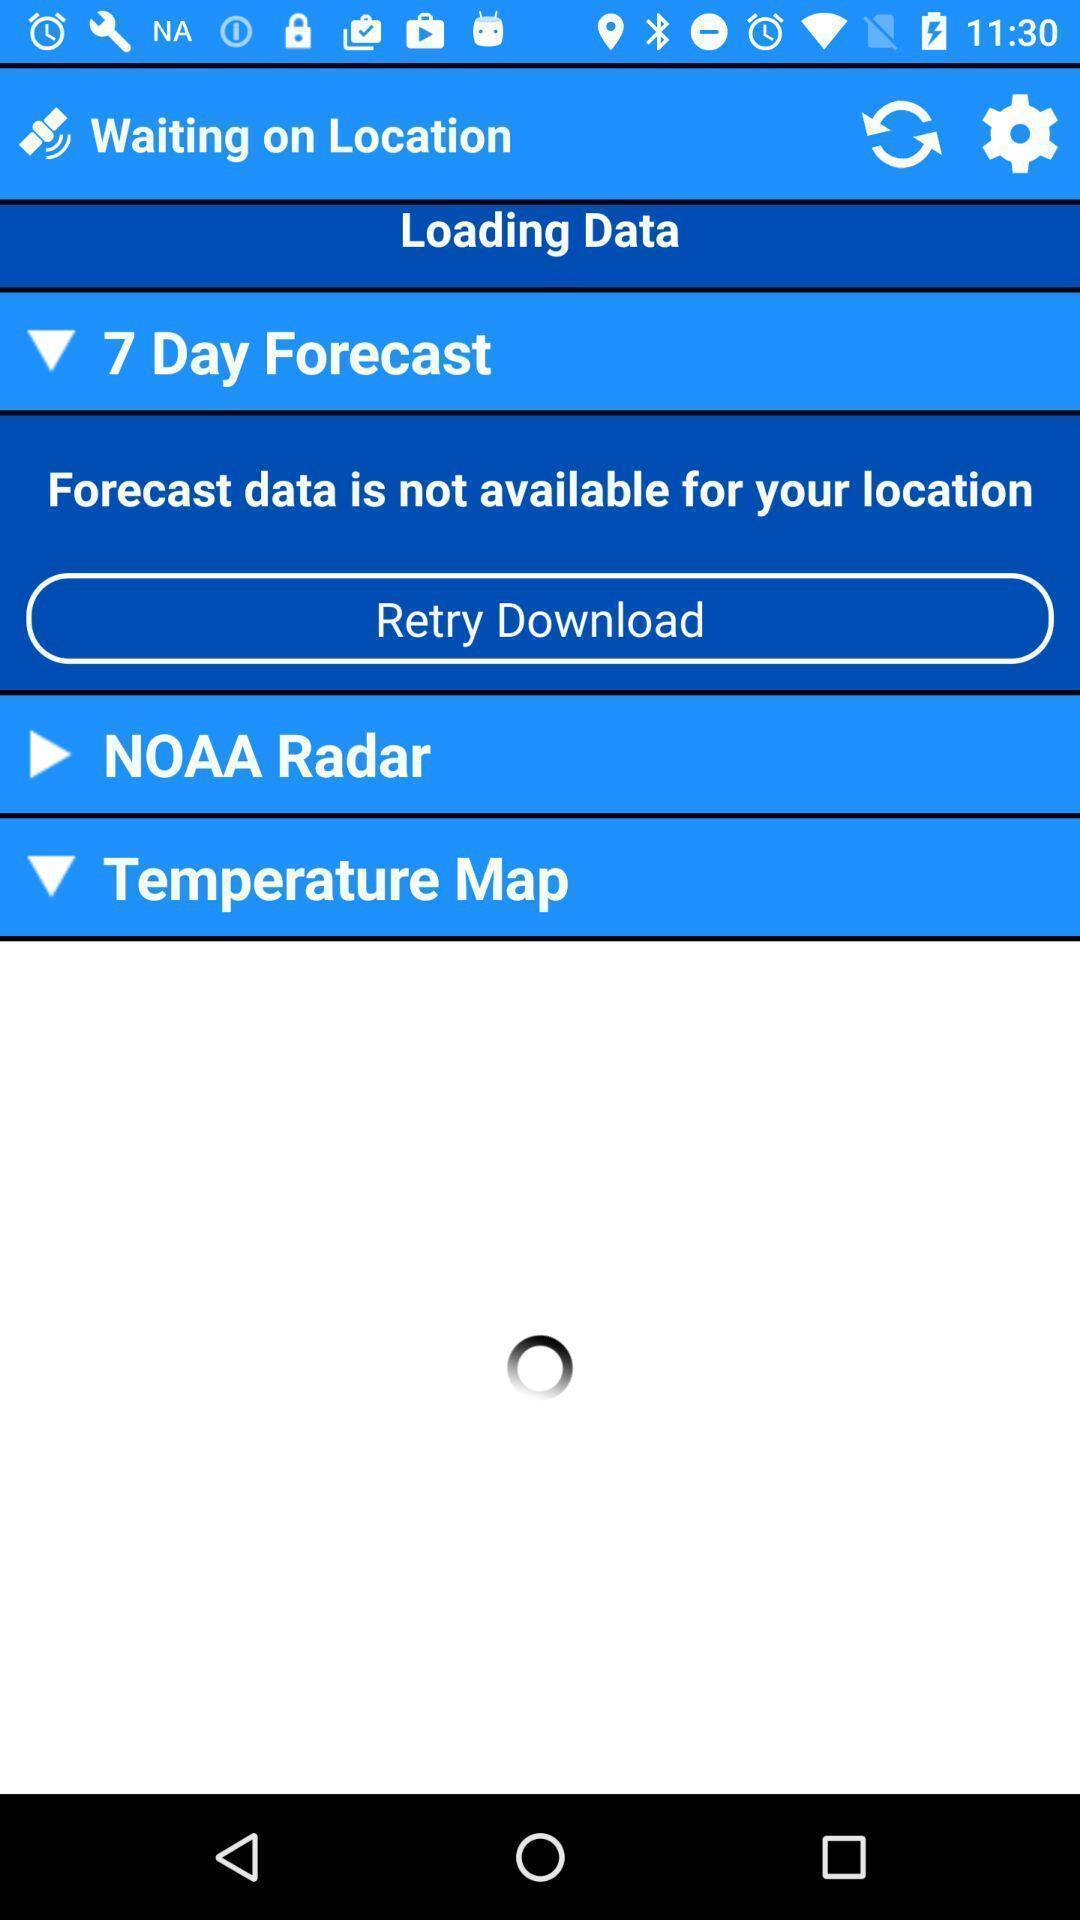Give me a summary of this screen capture. Screen shows weather details. 